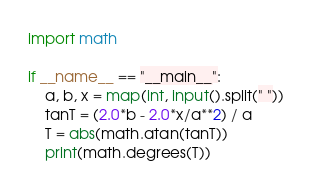<code> <loc_0><loc_0><loc_500><loc_500><_Python_>import math

if __name__ == "__main__":
    a, b, x = map(int, input().split(" "))
    tanT = (2.0*b - 2.0*x/a**2) / a
    T = abs(math.atan(tanT))
    print(math.degrees(T))
</code> 